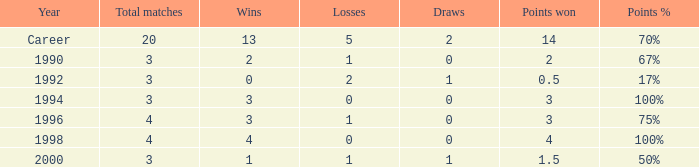Can you tell me the lowest Total natches that has the Points won of 3, and the Year of 1994? 3.0. 